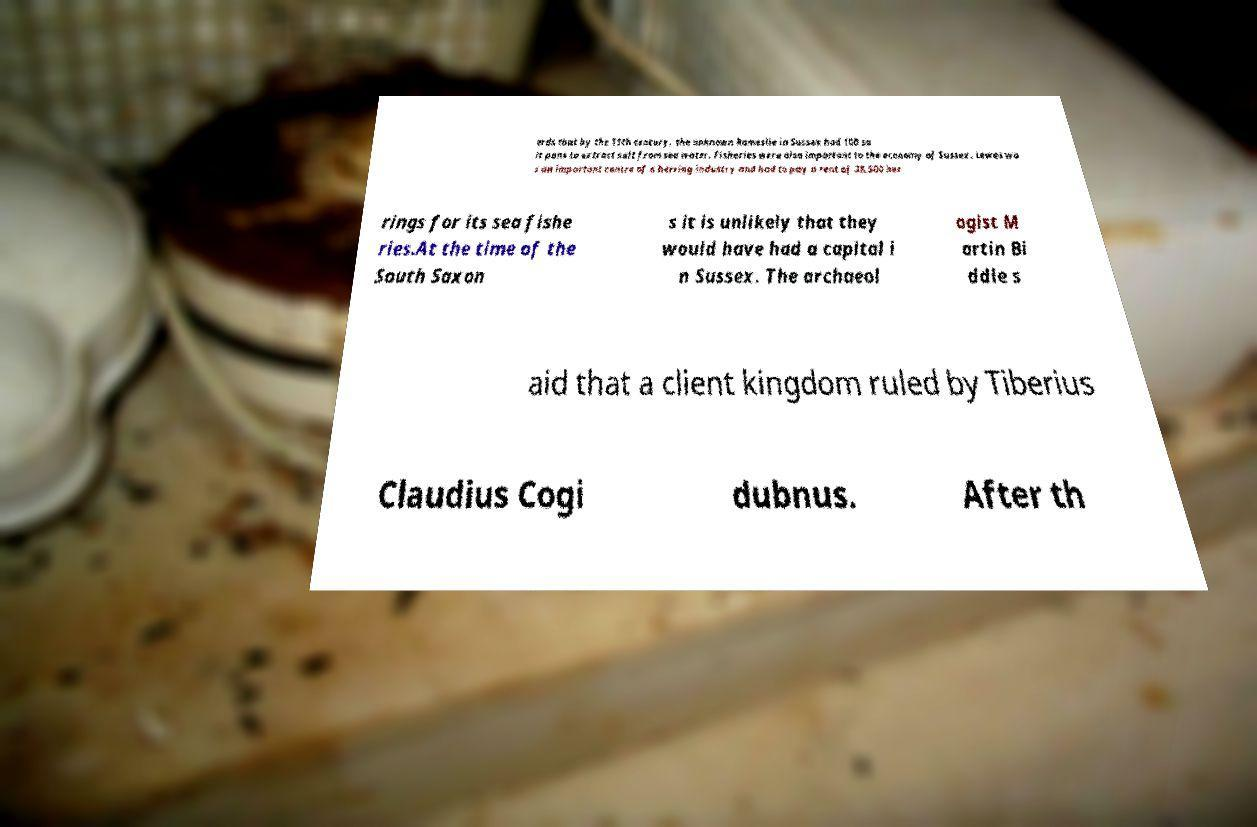Can you read and provide the text displayed in the image?This photo seems to have some interesting text. Can you extract and type it out for me? ords that by the 11th century, the unknown Rameslie in Sussex had 100 sa lt pans to extract salt from sea water. Fisheries were also important to the economy of Sussex. Lewes wa s an important centre of a herring industry and had to pay a rent of 38,500 her rings for its sea fishe ries.At the time of the South Saxon s it is unlikely that they would have had a capital i n Sussex. The archaeol ogist M artin Bi ddle s aid that a client kingdom ruled by Tiberius Claudius Cogi dubnus. After th 